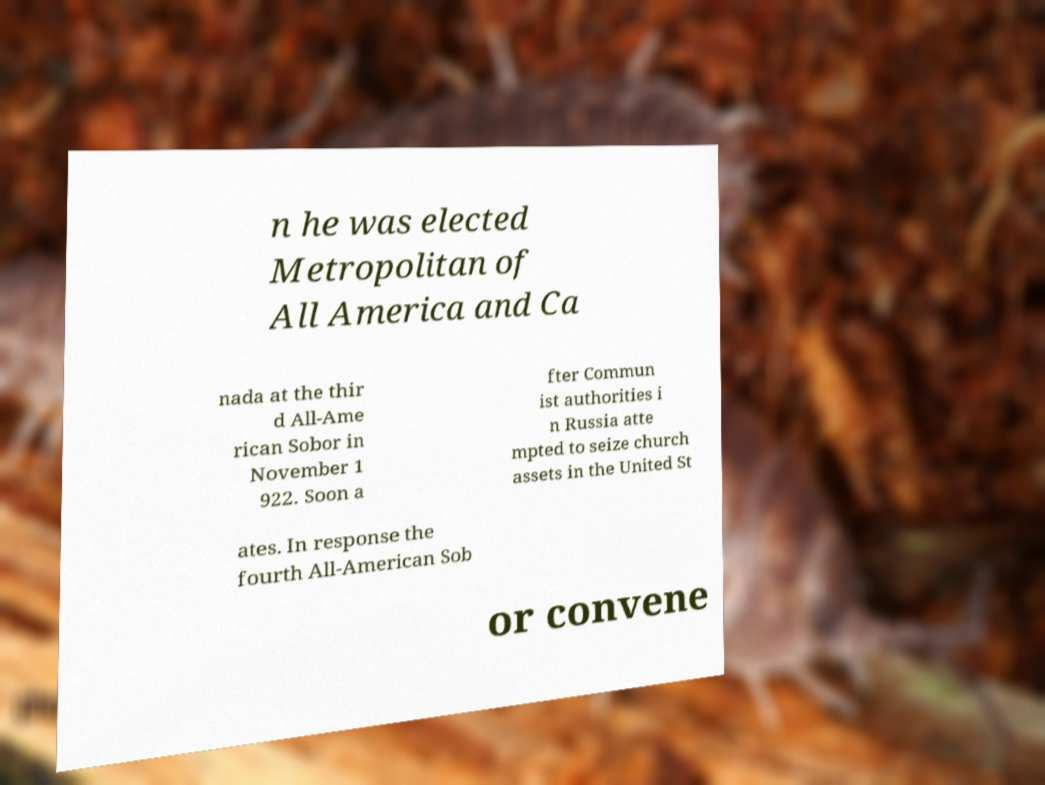Please read and relay the text visible in this image. What does it say? n he was elected Metropolitan of All America and Ca nada at the thir d All-Ame rican Sobor in November 1 922. Soon a fter Commun ist authorities i n Russia atte mpted to seize church assets in the United St ates. In response the fourth All-American Sob or convene 